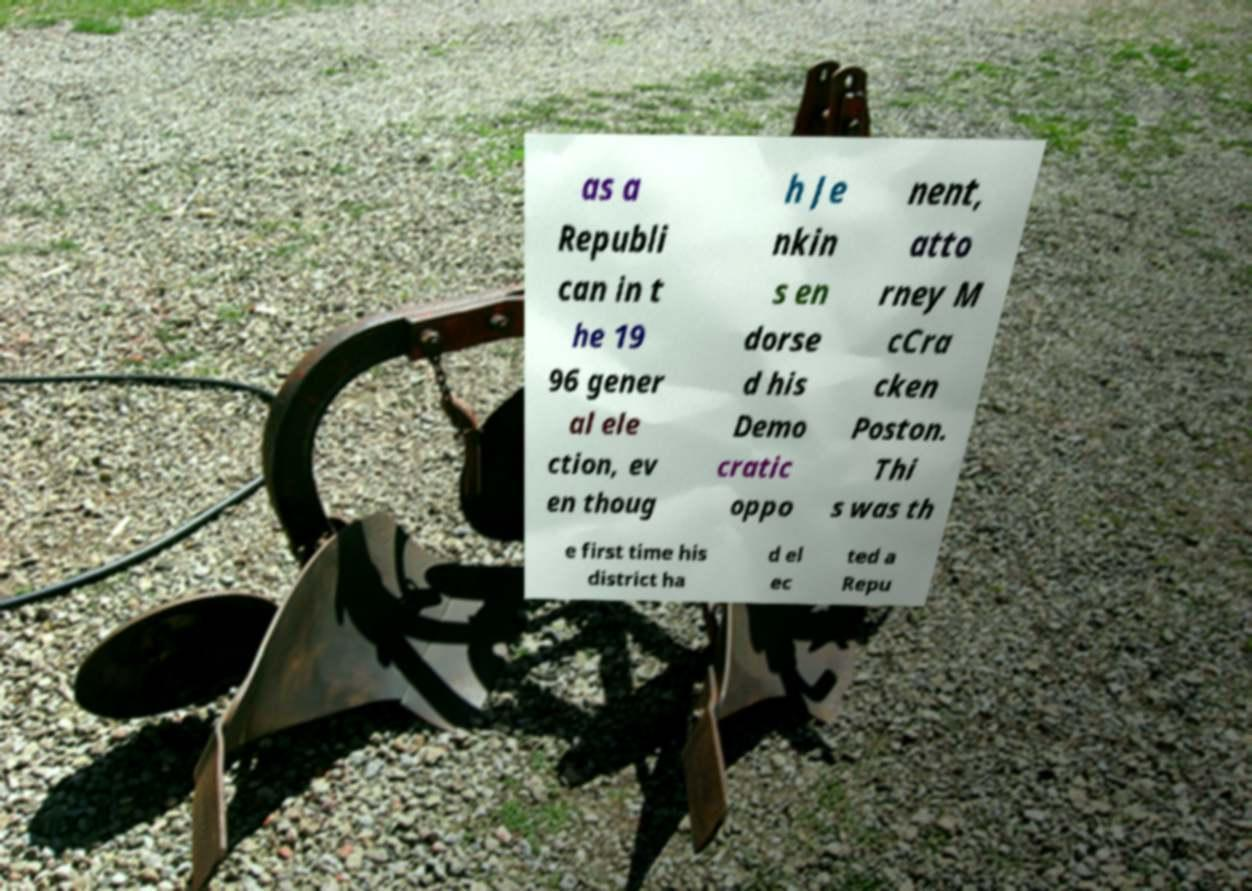Can you accurately transcribe the text from the provided image for me? as a Republi can in t he 19 96 gener al ele ction, ev en thoug h Je nkin s en dorse d his Demo cratic oppo nent, atto rney M cCra cken Poston. Thi s was th e first time his district ha d el ec ted a Repu 